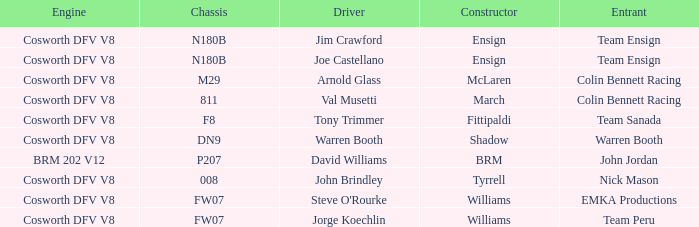Who was responsible for assembling warren booth's car equipped with a cosworth dfv v8 engine? Shadow. 